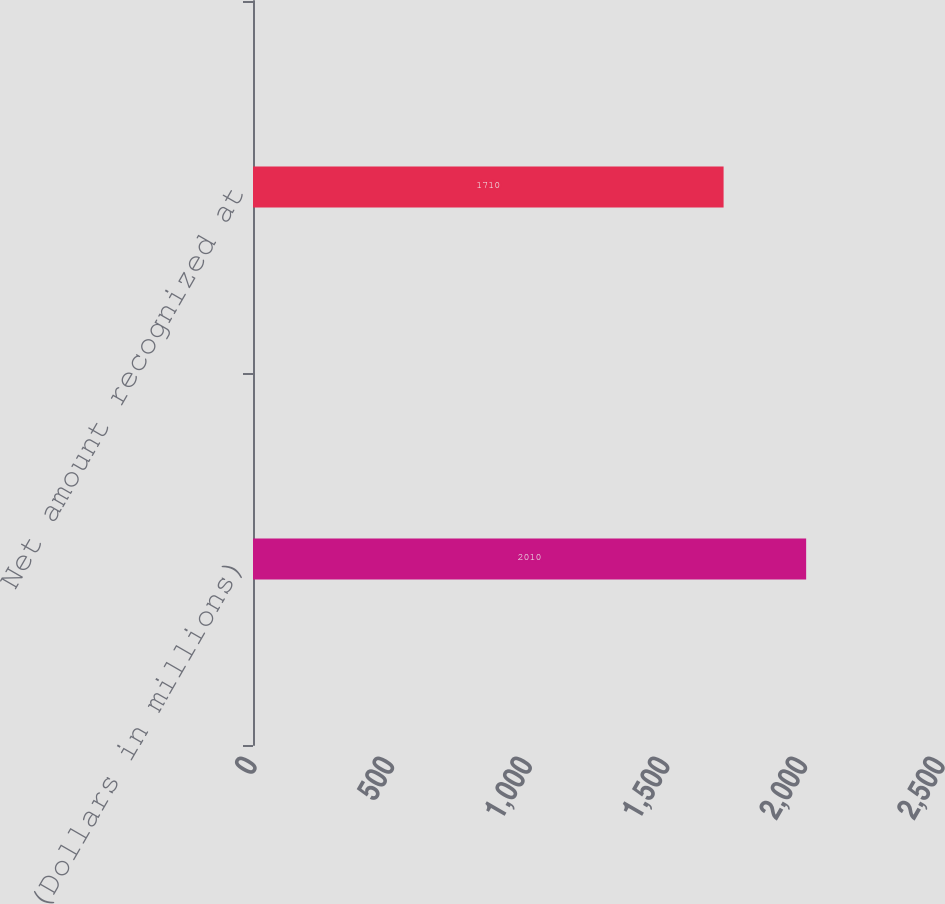<chart> <loc_0><loc_0><loc_500><loc_500><bar_chart><fcel>(Dollars in millions)<fcel>Net amount recognized at<nl><fcel>2010<fcel>1710<nl></chart> 